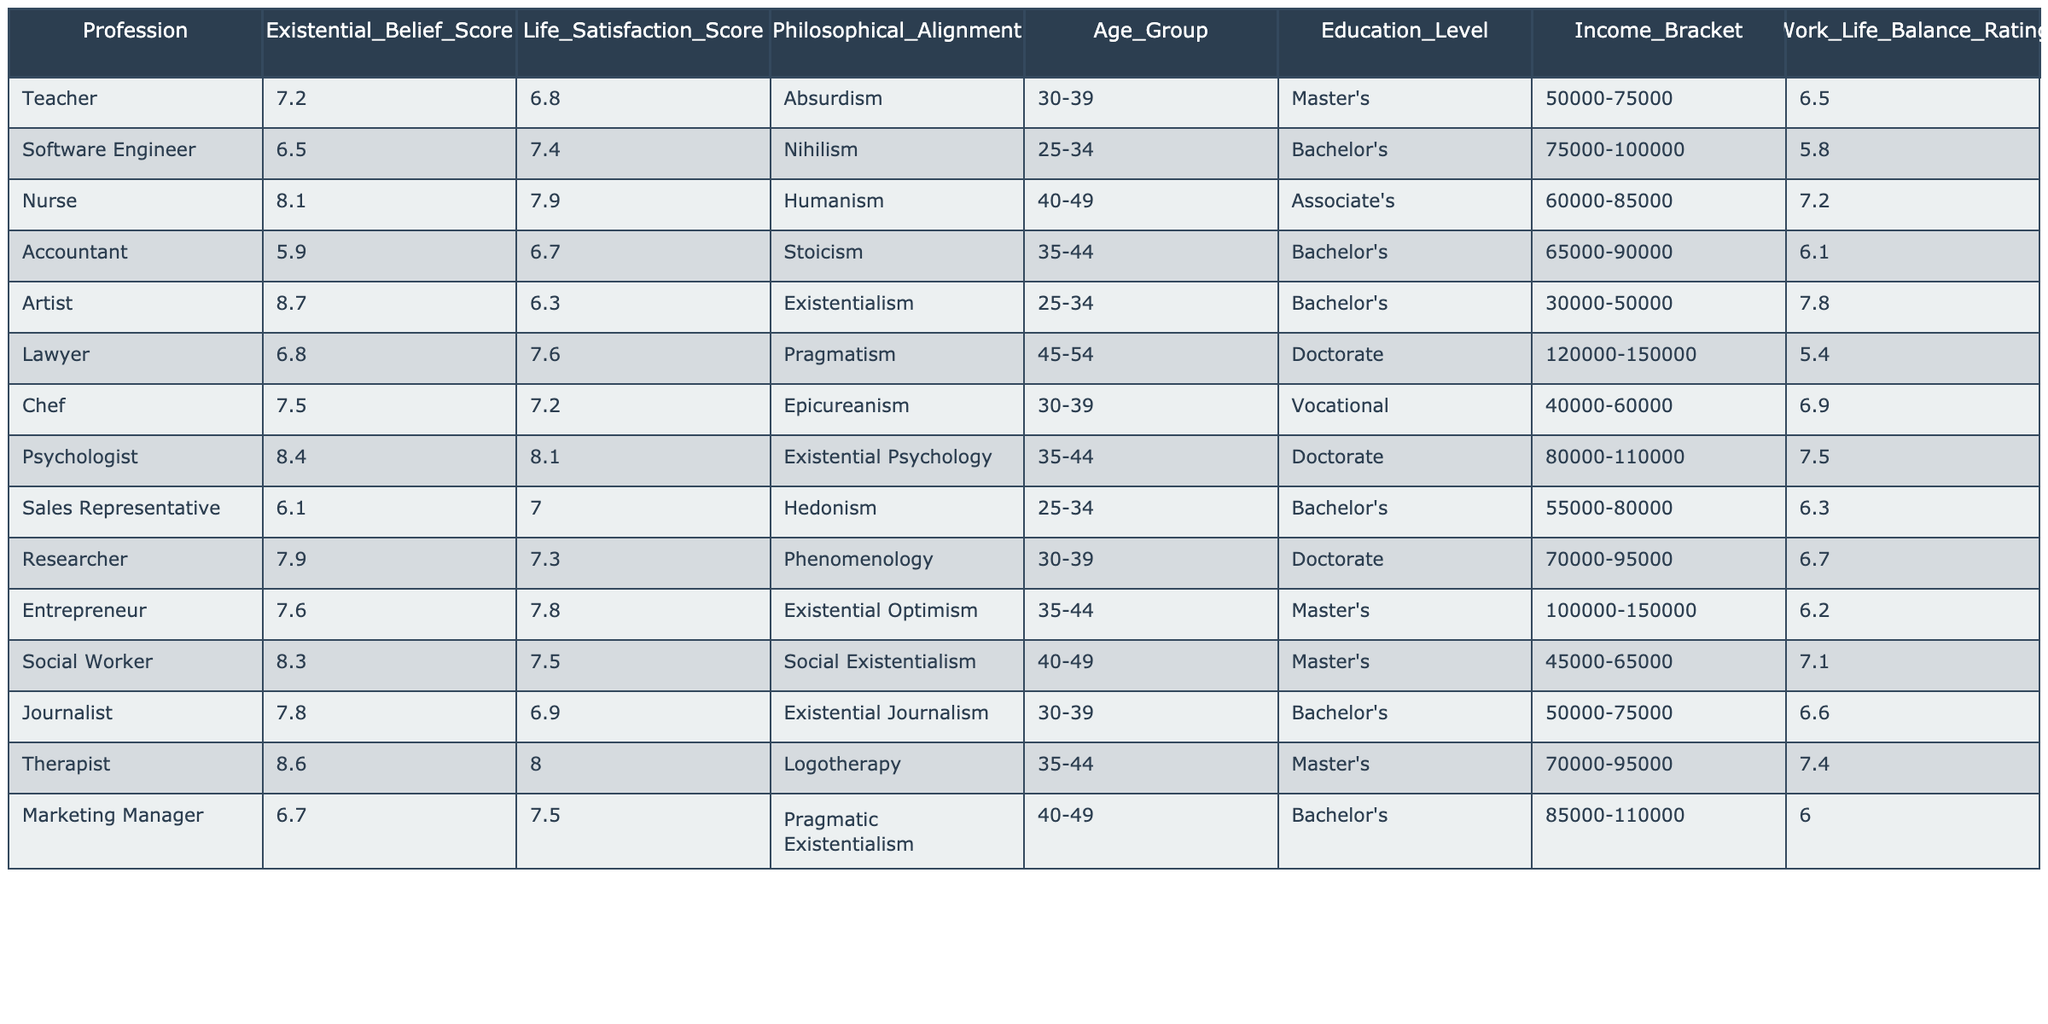What is the highest Life Satisfaction Score among the professions listed? By examining the Life Satisfaction Score column, we see that the Psychologist has the highest score of 8.1.
Answer: 8.1 What Existential Belief Score does the Artist hold? Referring to the Existential Belief Score column, the Artist has a score of 8.7.
Answer: 8.7 Which profession has the lowest Income Bracket? Looking at the Income Bracket column, the Artist has the lowest range of 30000-50000.
Answer: Artist What is the average Life Satisfaction Score across all professions? Summing the Life Satisfaction Scores (6.8 + 7.4 + 7.9 + 6.7 + 6.3 + 7.6 + 7.2 + 8.1 + 7.0 + 7.3 + 7.8 + 7.5 + 6.9 + 8.0 + 7.5) gives 106.2. There are 15 scores, so the average is 106.2 / 15 ≈ 7.08.
Answer: 7.08 Is there a profession that has both the highest Existential Belief Score and a Life Satisfaction Score above 8? The Psychologist has an Existential Belief Score of 8.4, which is the highest in its category. Additionally, this profession also has a Life Satisfaction Score of 8.1, which is indeed above 8.
Answer: Yes How does the Life Satisfaction Score for Nurses compare to that of Lawyers? The Nurse has a Life Satisfaction Score of 7.9, whereas the Lawyer's score is 7.6. Comparing these, Nurses have a higher Life Satisfaction Score than Lawyers.
Answer: Nurses have a higher score Which profession represents the Philosophical Alignment of Existentialism? From the Philosophical Alignment column, the Artist's profession is categorized under Existentialism.
Answer: Artist What is the Work-Life Balance Rating for the Sales Representative? The Work Life Balance Rating column indicates that the Sales Representative has a rating of 6.3.
Answer: 6.3 Which profession has the highest Existential Belief Score and what is that score? The Artist holds the highest Existential Belief Score of 8.7 among all the professions listed.
Answer: 8.7 Are there more professions with a Life Satisfaction Score above 7.5 than below? The professions with scores above 7.5 are Nurse, Psychologist, Therapist, and Entrepreneur, totaling 4, while the ones below are Artist, Software Engineer, Accountant, Sales Representative, and Marketing Manager, totaling 6. Therefore, there are more professions below 7.5.
Answer: No What is the difference in Life Satisfaction Scores between Psychologists and Accountants? The Psychologist has a score of 8.1, while the Accountant has 6.7. The difference is 8.1 - 6.7 = 1.4.
Answer: 1.4 